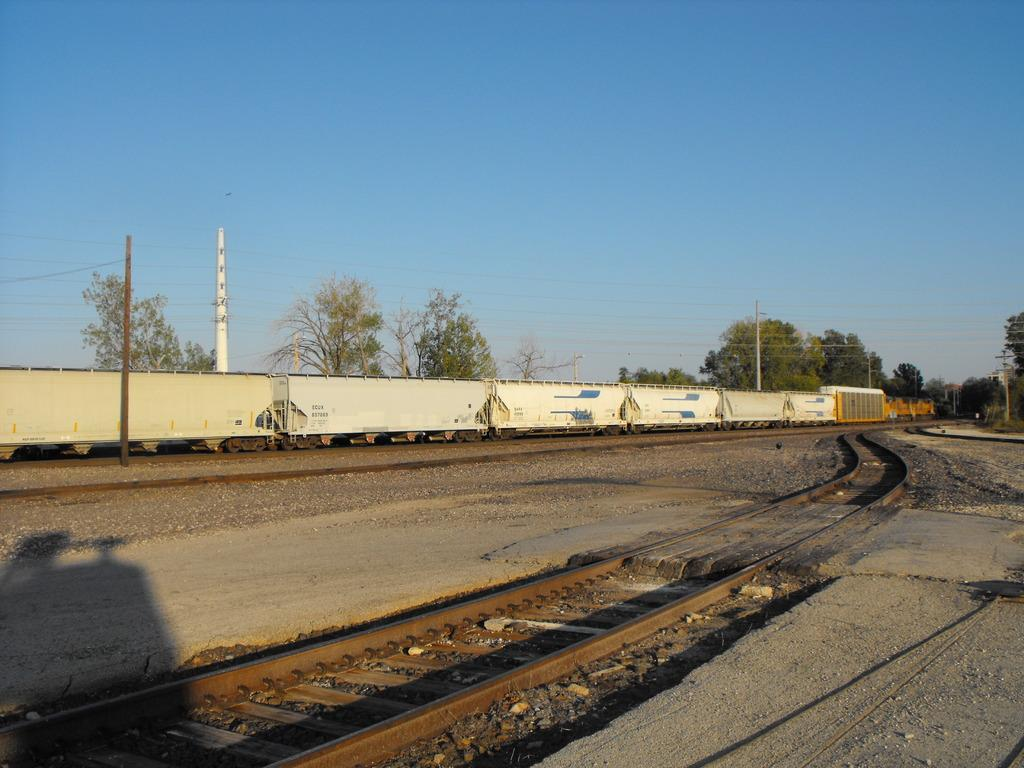What is the main subject of the image? The main subject of the image is a train on the track. What type of terrain can be seen in the image? There are stones and a group of trees visible in the image. What structures are present in the image? There are poles with wires in the image. What is the condition of the sky in the image? The sky is visible in the image and appears cloudy. Can you hear the train crying in the image? There is no indication of sound in the image, and trains do not cry. Is there a cave visible in the image? There is no cave present in the image. 